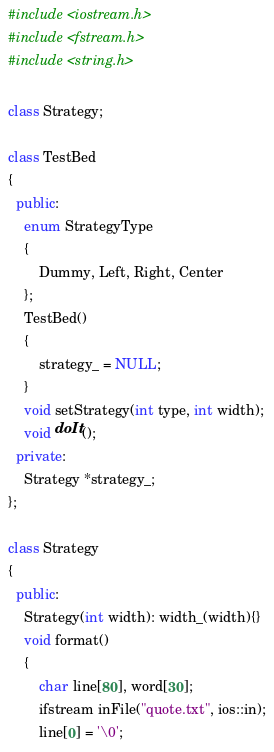Convert code to text. <code><loc_0><loc_0><loc_500><loc_500><_C++_>#include <iostream.h>
#include <fstream.h>
#include <string.h>

class Strategy;

class TestBed
{
  public:
    enum StrategyType
    {
        Dummy, Left, Right, Center
    };
    TestBed()
    {
        strategy_ = NULL;
    }
    void setStrategy(int type, int width);
    void doIt();
  private:
    Strategy *strategy_;
};

class Strategy
{
  public:
    Strategy(int width): width_(width){}
    void format()
    {
        char line[80], word[30];
        ifstream inFile("quote.txt", ios::in);
        line[0] = '\0';
</code> 